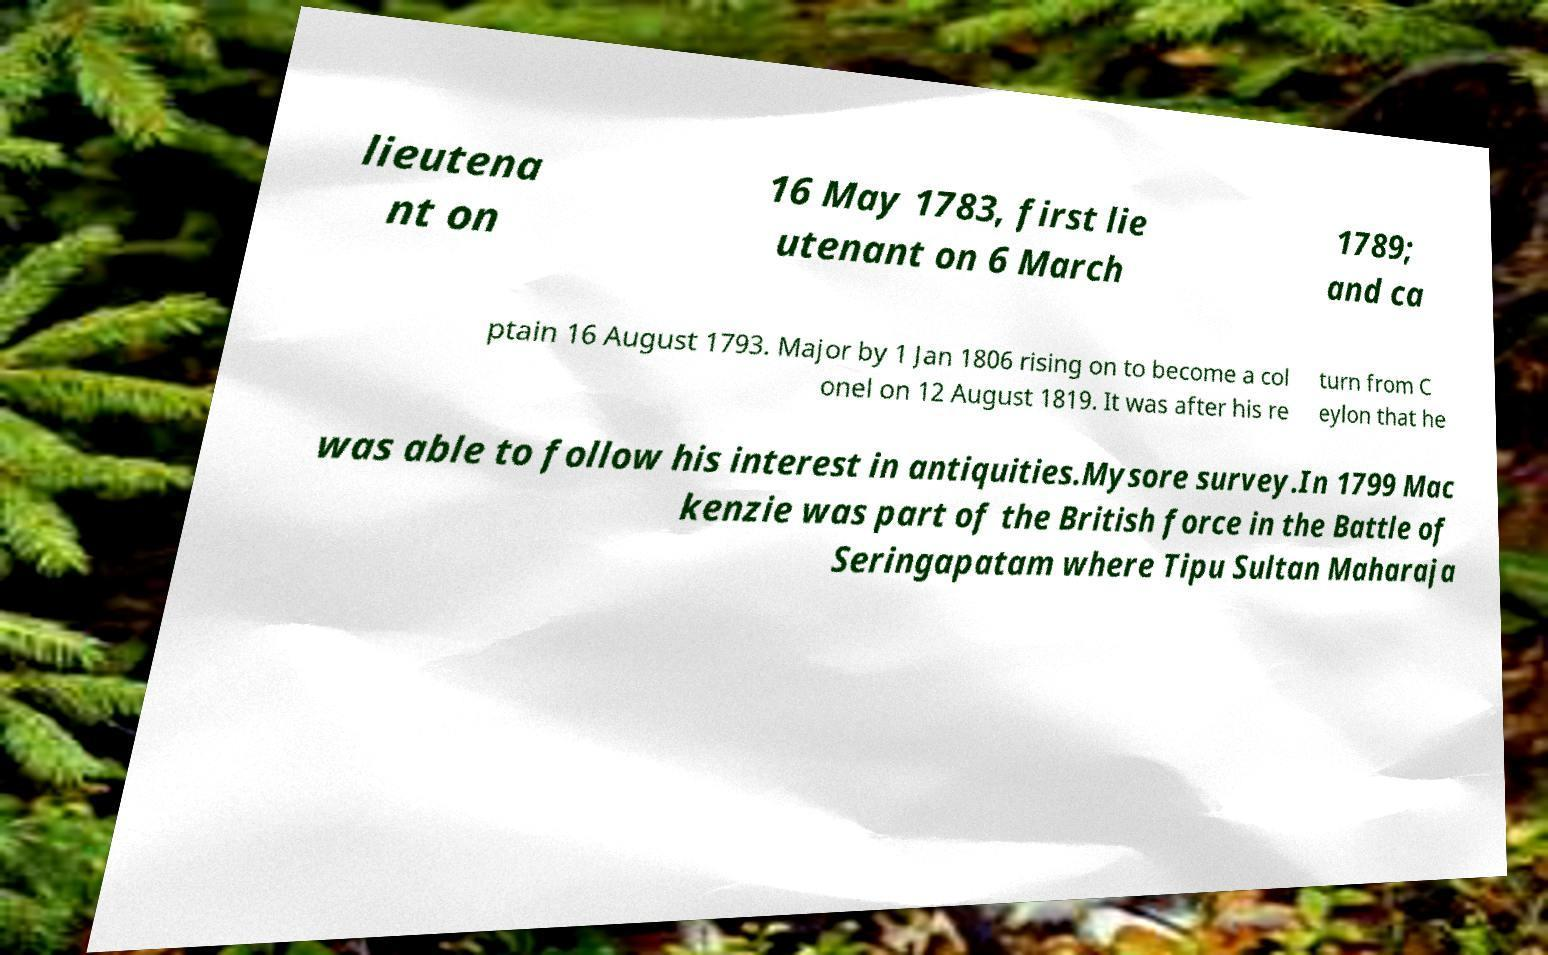For documentation purposes, I need the text within this image transcribed. Could you provide that? lieutena nt on 16 May 1783, first lie utenant on 6 March 1789; and ca ptain 16 August 1793. Major by 1 Jan 1806 rising on to become a col onel on 12 August 1819. It was after his re turn from C eylon that he was able to follow his interest in antiquities.Mysore survey.In 1799 Mac kenzie was part of the British force in the Battle of Seringapatam where Tipu Sultan Maharaja 